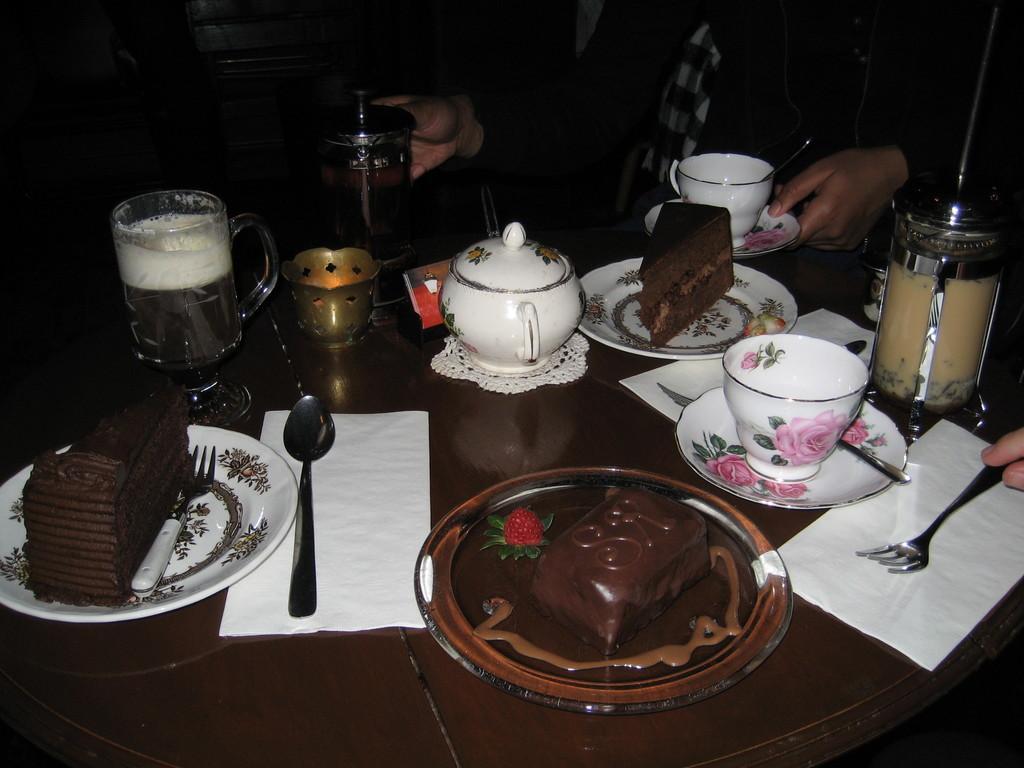Describe this image in one or two sentences. in this image there is tea pot , plate , chocolate , fork, napkin , saucer , cake , fork in the table in back ground there is person. 